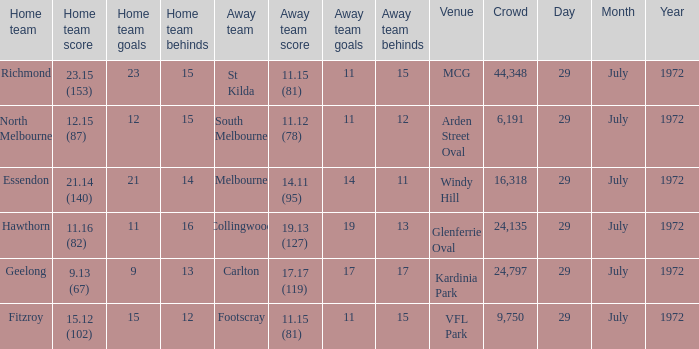What was the largest crowd size at arden street oval? 6191.0. 